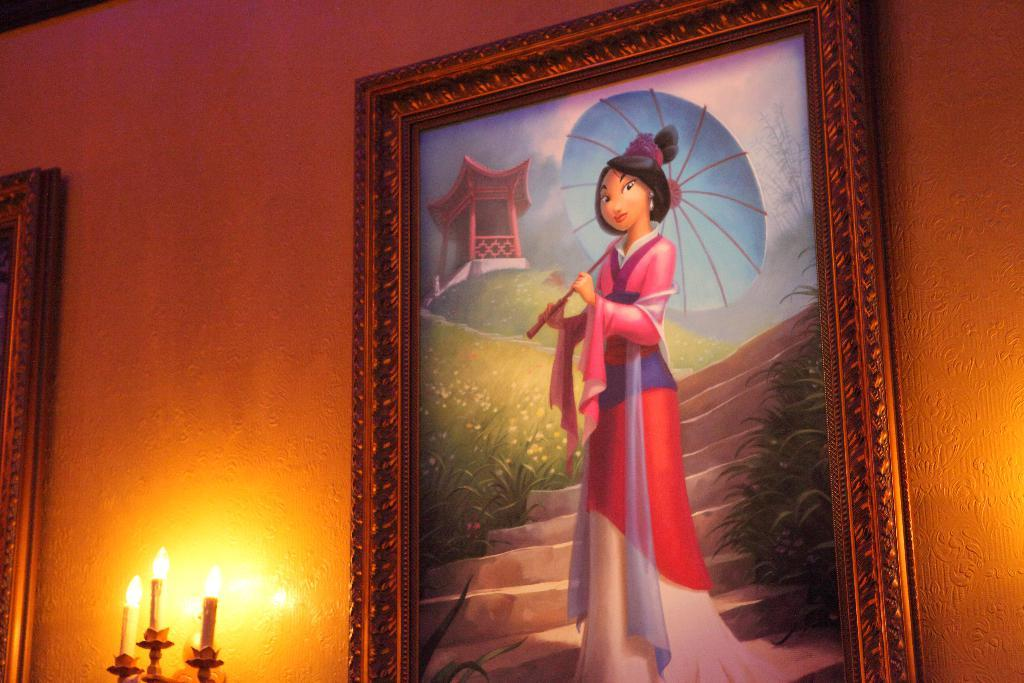What is present on the wall in the image? There are photo frames on the wall. What is depicted in the photo frames? The painting on the photo frame depicts a lady holding an umbrella and includes plants and steps. Are there any light sources visible in the image? Yes, there are candles with lights in the image. What is the primary purpose of the photo frames in the image? The primary purpose of the photo frames is to display the paintings. What type of cookware is being used to cover the candles in the image? There is no cookware present in the image, nor are the candles being covered. 